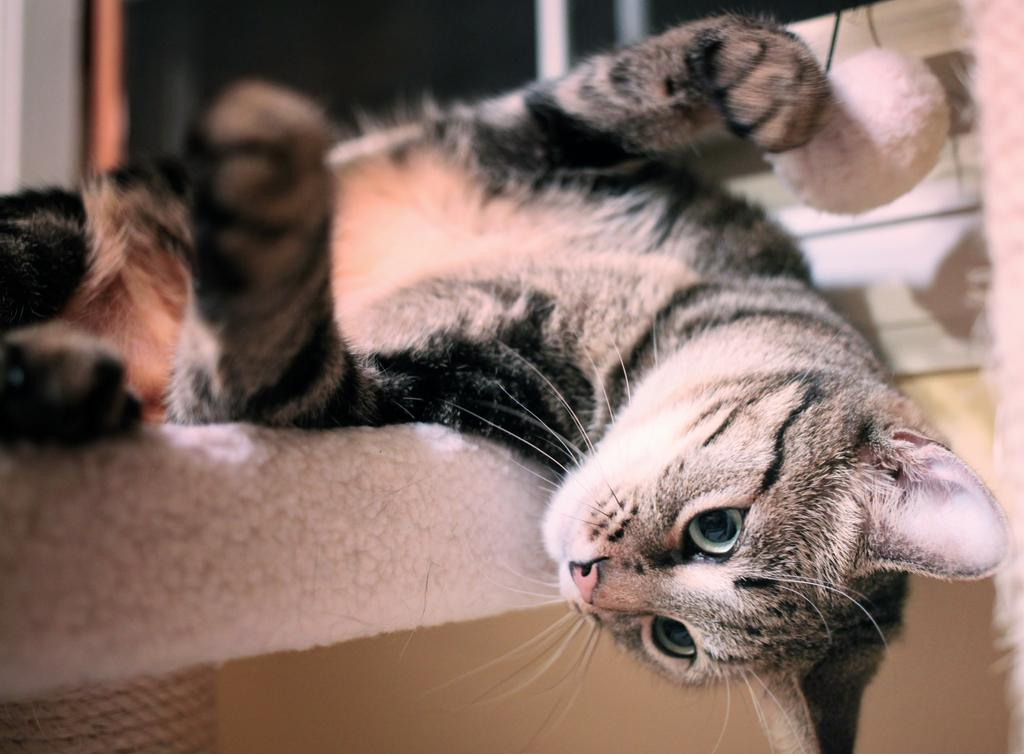What animal is present in the image? There is a cat in the image. What is the cat laying on? The cat is laying on a white surface. Can you describe the background of the image? The background of the image is blurred. What type of hammer is the stranger holding in the image? There is no stranger or hammer present in the image; it features a cat laying on a white surface with a blurred background. 